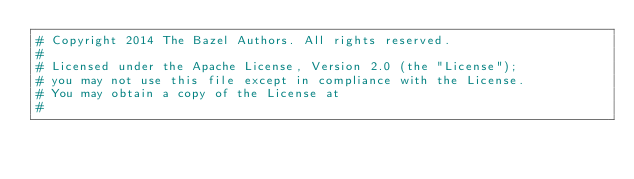Convert code to text. <code><loc_0><loc_0><loc_500><loc_500><_Python_># Copyright 2014 The Bazel Authors. All rights reserved.
#
# Licensed under the Apache License, Version 2.0 (the "License");
# you may not use this file except in compliance with the License.
# You may obtain a copy of the License at
#</code> 